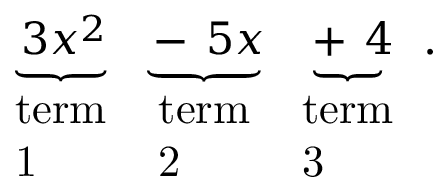Convert formula to latex. <formula><loc_0><loc_0><loc_500><loc_500>\underbrace { _ { \, } 3 x ^ { 2 } } _ { \begin{array} { l } { t e r m } \\ { 1 } \end{array} } \underbrace { - _ { \, } 5 x } _ { \begin{array} { l } { t e r m } \\ { 2 } \end{array} } \underbrace { + _ { \, } 4 } _ { \begin{array} { l } { t e r m } \\ { 3 } \end{array} } .</formula> 